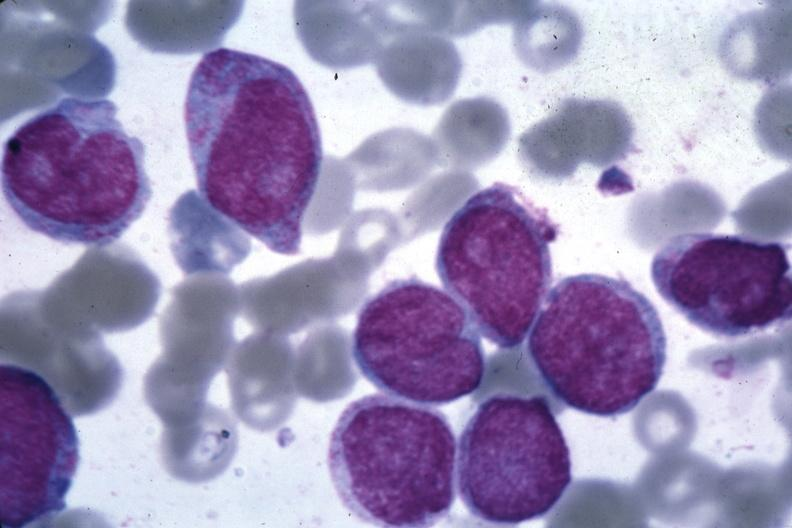s hematologic present?
Answer the question using a single word or phrase. Yes 